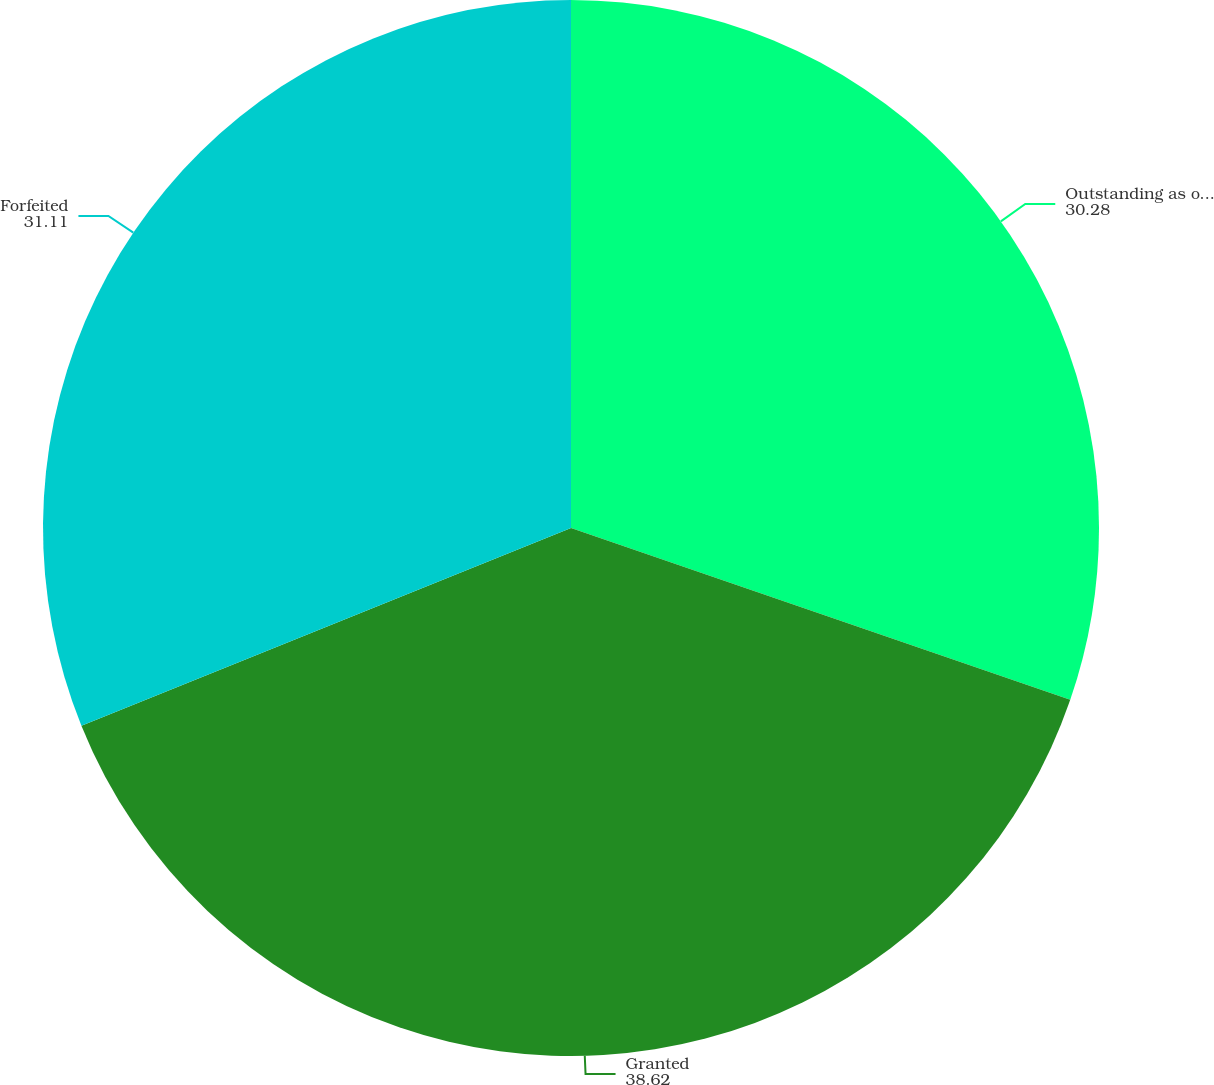Convert chart to OTSL. <chart><loc_0><loc_0><loc_500><loc_500><pie_chart><fcel>Outstanding as of December 31<fcel>Granted<fcel>Forfeited<nl><fcel>30.28%<fcel>38.62%<fcel>31.11%<nl></chart> 